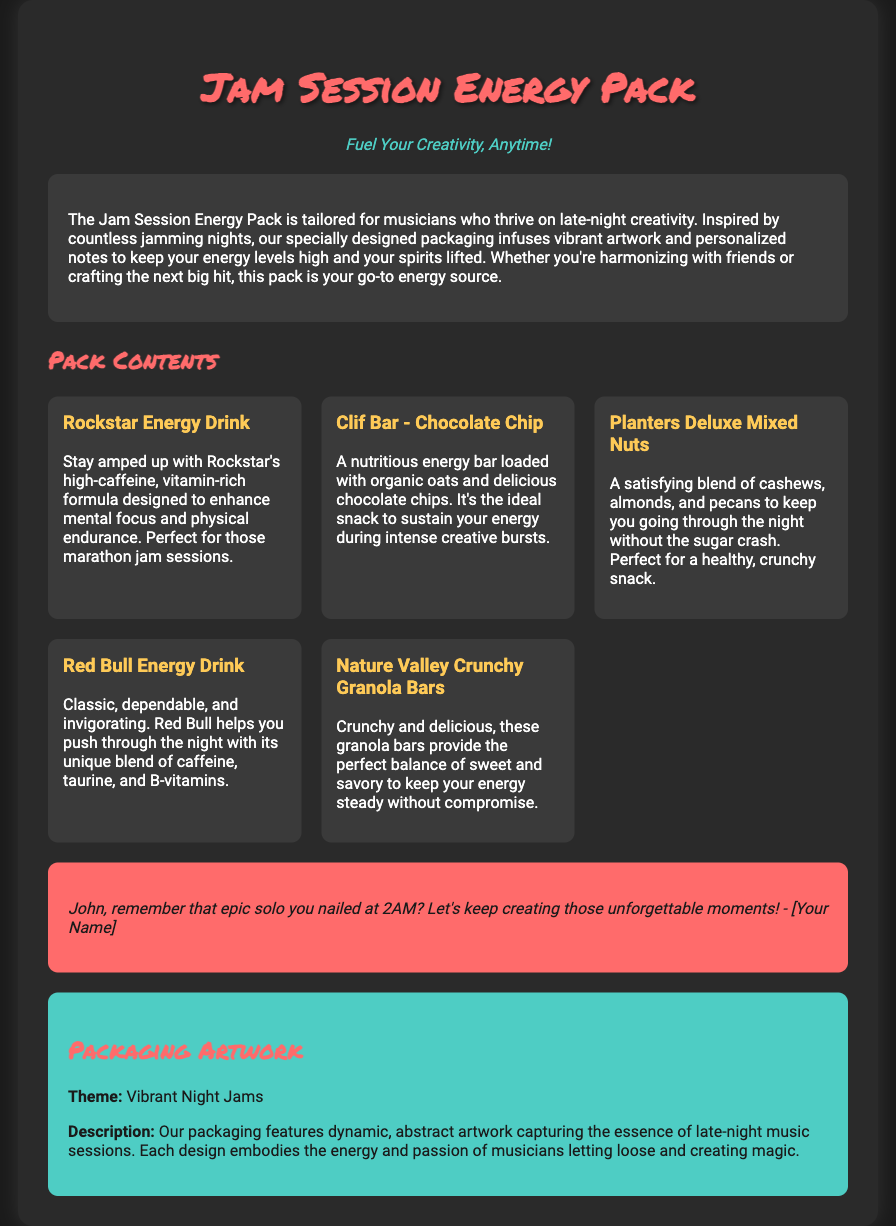What is the name of the energy pack? The name of the energy pack is clearly stated at the top of the document.
Answer: Jam Session Energy Pack What is the slogan of the energy pack? The slogan, which captures the essence of the product, is prominently displayed underneath the title.
Answer: Fuel Your Creativity, Anytime! What is included in the pack? The document lists several items that are part of the pack.
Answer: Rockstar Energy Drink, Clif Bar - Chocolate Chip, Planters Deluxe Mixed Nuts, Red Bull Energy Drink, Nature Valley Crunchy Granola Bars What type of drink is Rockstar? The document describes the characteristics of the drink in a specific section of the contents.
Answer: Energy Drink What note is included in the packaging? The document features a personalized note aimed at a certain John, indicating a connection.
Answer: John, remember that epic solo you nailed at 2AM? Let's keep creating those unforgettable moments! - [Your Name] What is the theme of the artwork? The theme of the packaging artwork is mentioned in the dedicated section explaining its design.
Answer: Vibrant Night Jams How does the packaging describe its artwork? The document gives a short description of what the artwork aims to capture regarding musician experiences.
Answer: The essence of late-night music sessions How many energy drinks are listed in the pack? The pack lists specific drinks, and a count can be derived from the document.
Answer: Two What is the target audience of the energy pack? The description section specifies who the energy pack is designed for, reflecting their needs.
Answer: Musicians 